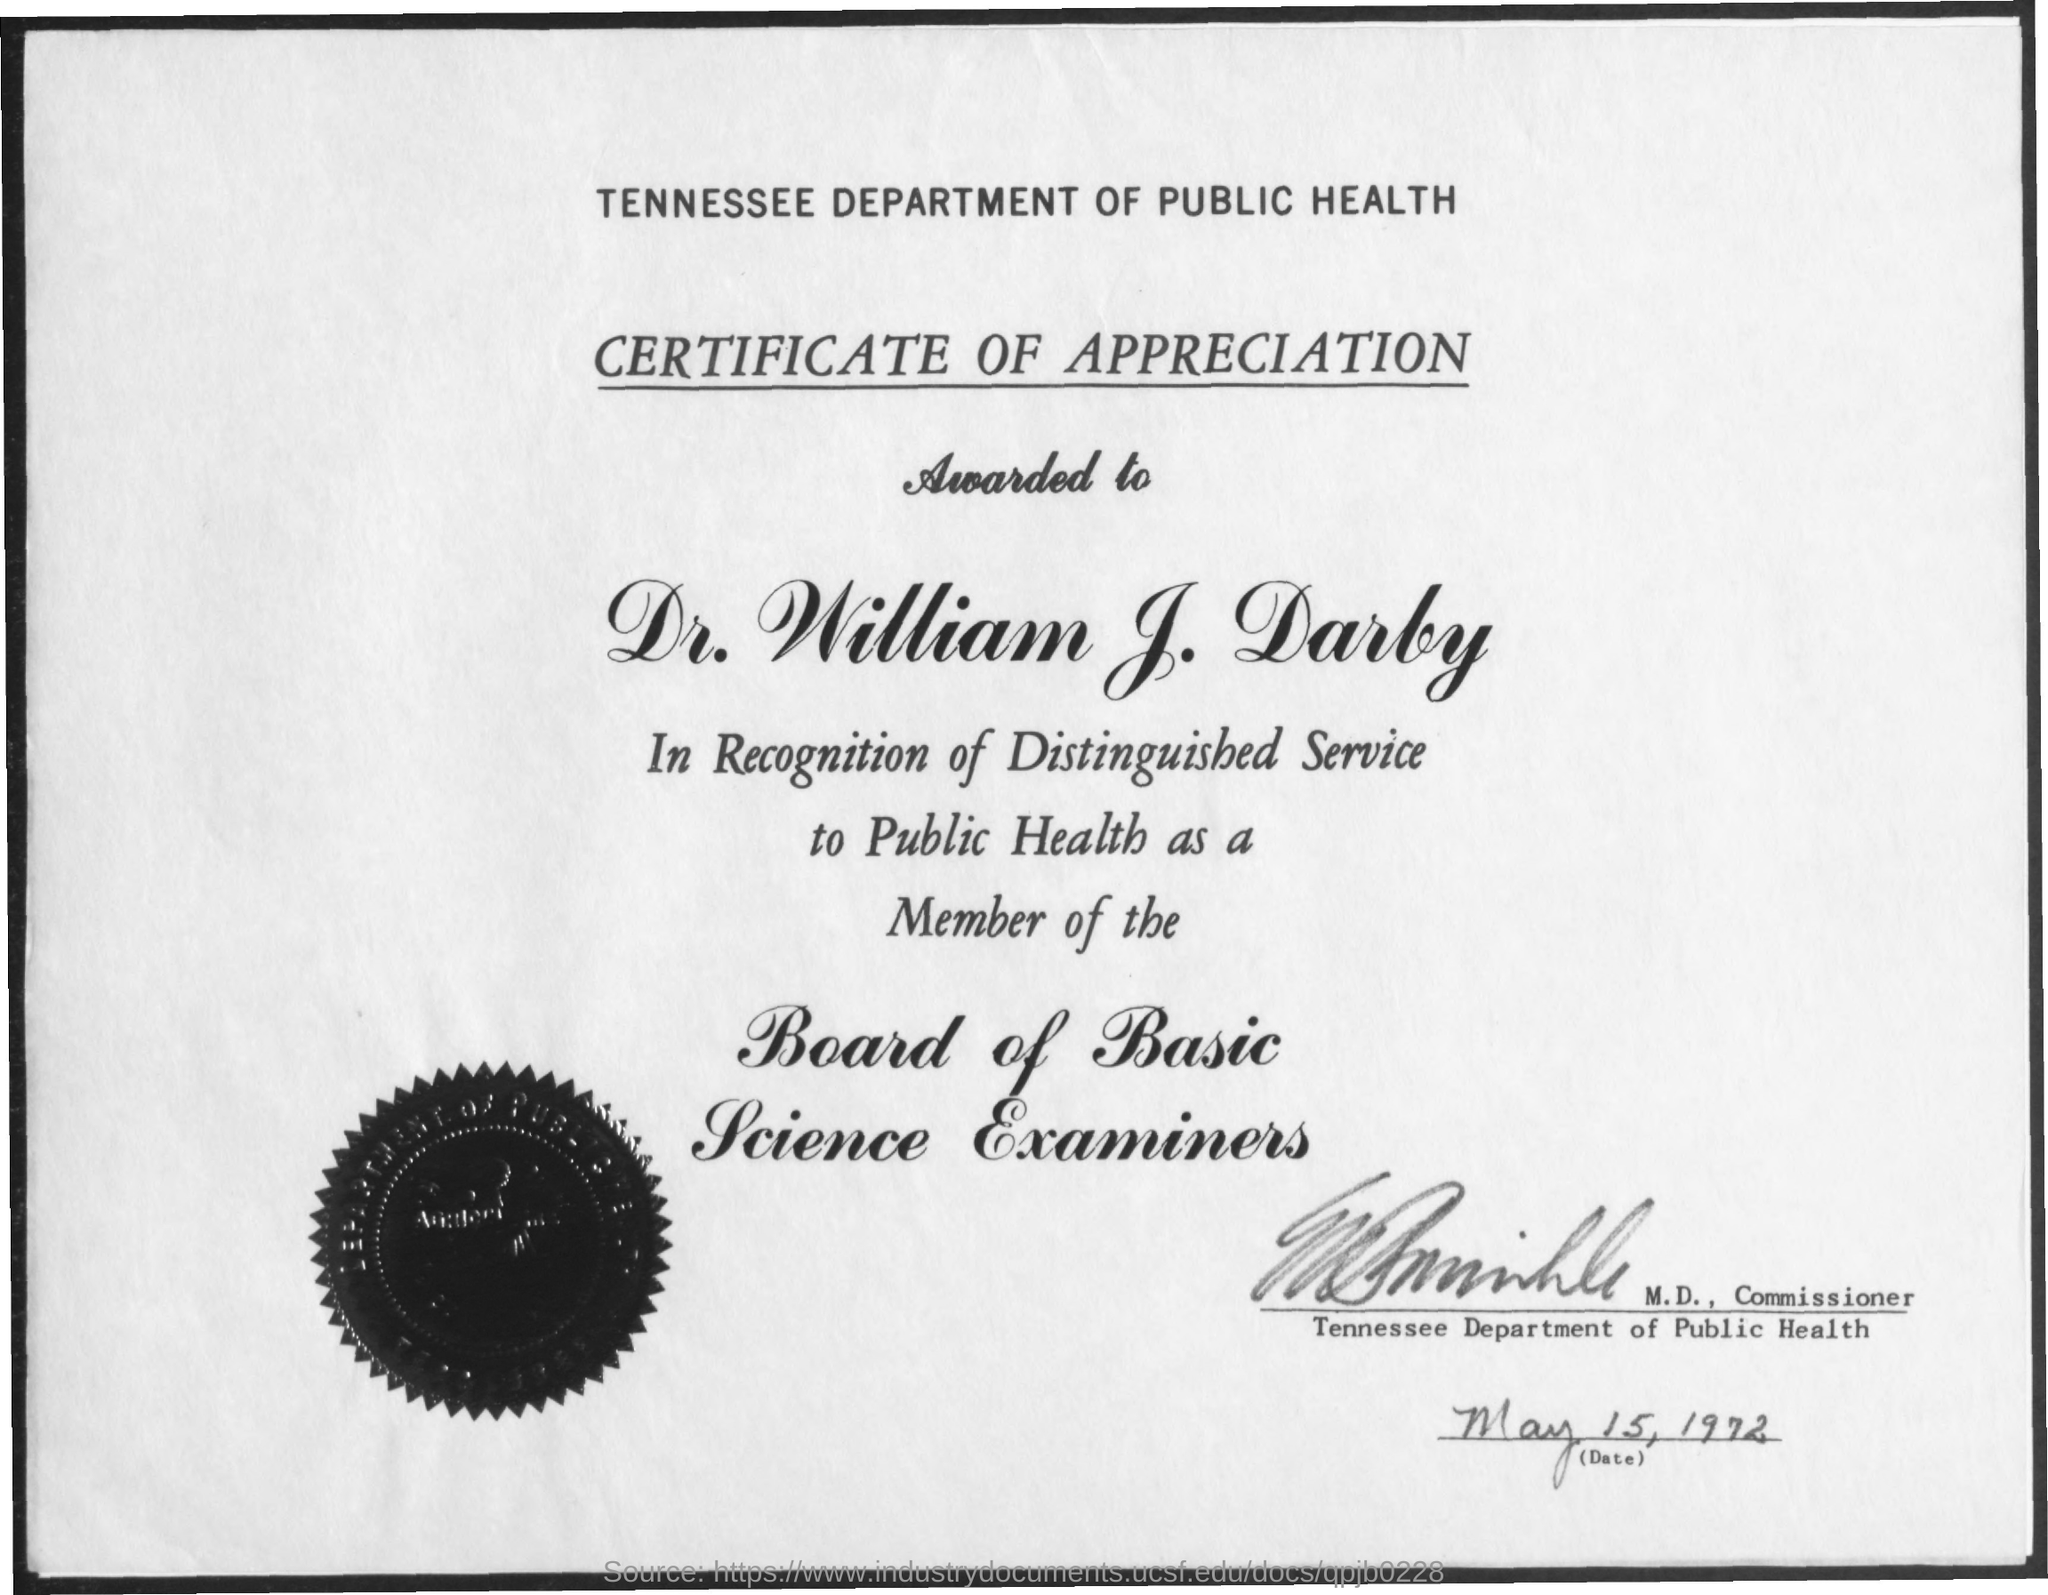Outline some significant characteristics in this image. The Board of Basic Science Examiners is a board that is about the topic of basic science. The Tennessee Department of Public Health is mentioned. The certificate is about appreciation. 